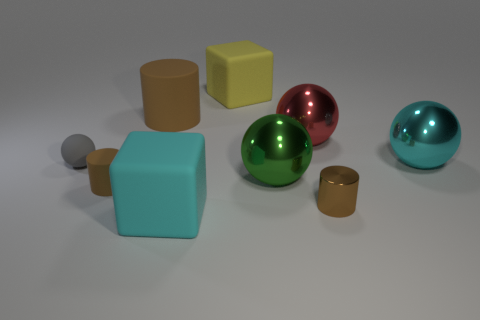How many objects are in the image? There are a total of seven objects in the image: four spheres and three cubes. Do the objects seem to follow a particular pattern or arrangement? The objects do not follow a strict pattern but are arranged with a balance between the various shapes and colors, spaced out in a way that is pleasing to the eye and gives the composition a sense of harmony. 